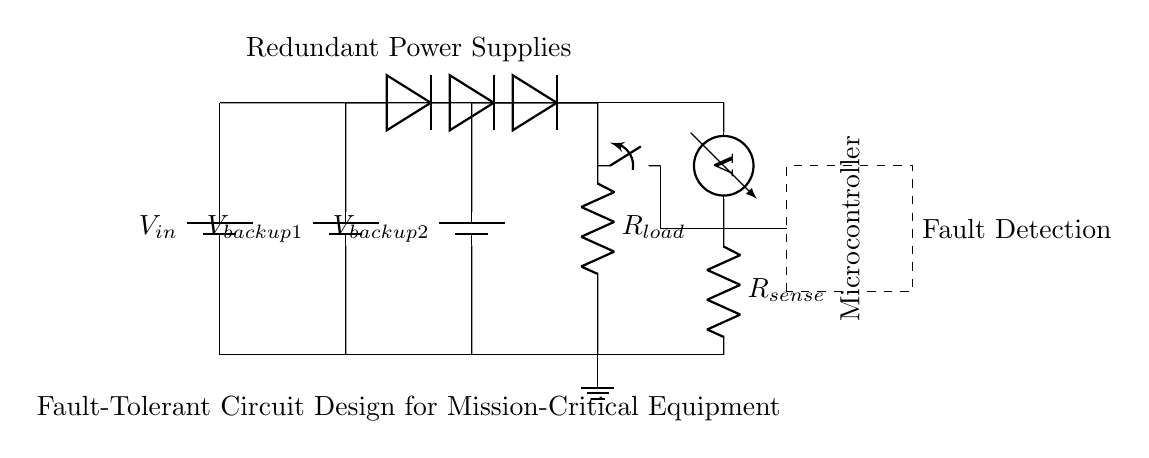What is the input voltage of the circuit? The input voltage is indicated by the label $V_{in}$ connected to the main power supply. It is the primary voltage source that powers the load.
Answer: V_in How many power supplies are there in this circuit? The circuit includes three power supplies: the main power supply and two redundant backup supplies labeled $V_{backup1}$ and $V_{backup2}$.
Answer: 3 What component isolates the power supplies? Diodes are used for isolation between the power supplies and the load, ensuring that power supply faults do not affect the entire circuit.
Answer: Diodes What is the function of the fault detection circuit? The fault detection circuit, consisting of a voltmeter and a sense resistor, monitors the output voltage to detect any anomalies and trigger responses as necessary.
Answer: Monitor output voltage How does the microcontroller respond to a detected fault? The microcontroller, after receiving information from the fault detection circuit, can disconnect the load using the switch, protecting the circuit from potential damage.
Answer: Disconnect load What type of resistor is used in the circuit? The resistor connected to the load is a standard resistor labeled $R_{load}$, and there is also a sensing resistor labeled $R_{sense}$ in the fault detection circuit.
Answer: Resistors What type of load is represented in this circuit? The load is represented by the resistor labeled $R_{load}$, which represents the device or application the circuit is powering.
Answer: Resistor 